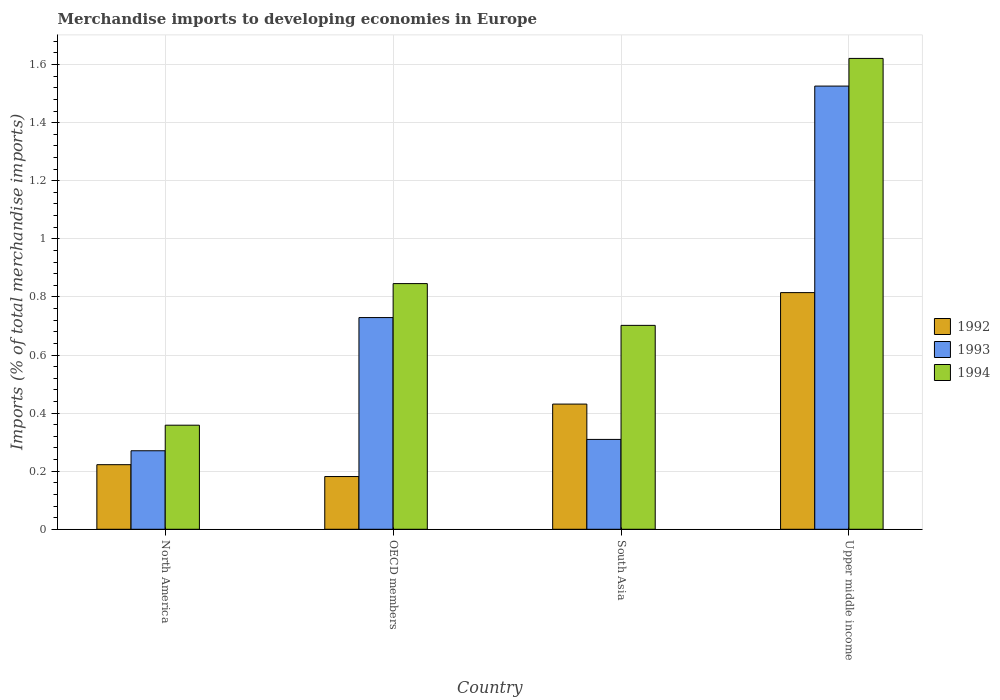How many different coloured bars are there?
Ensure brevity in your answer.  3. Are the number of bars per tick equal to the number of legend labels?
Provide a short and direct response. Yes. How many bars are there on the 3rd tick from the right?
Your answer should be compact. 3. What is the label of the 2nd group of bars from the left?
Ensure brevity in your answer.  OECD members. What is the percentage total merchandise imports in 1992 in South Asia?
Make the answer very short. 0.43. Across all countries, what is the maximum percentage total merchandise imports in 1993?
Keep it short and to the point. 1.53. Across all countries, what is the minimum percentage total merchandise imports in 1994?
Keep it short and to the point. 0.36. In which country was the percentage total merchandise imports in 1994 maximum?
Offer a terse response. Upper middle income. In which country was the percentage total merchandise imports in 1992 minimum?
Provide a succinct answer. OECD members. What is the total percentage total merchandise imports in 1994 in the graph?
Make the answer very short. 3.53. What is the difference between the percentage total merchandise imports in 1992 in North America and that in OECD members?
Your answer should be compact. 0.04. What is the difference between the percentage total merchandise imports in 1994 in North America and the percentage total merchandise imports in 1993 in South Asia?
Your answer should be compact. 0.05. What is the average percentage total merchandise imports in 1994 per country?
Give a very brief answer. 0.88. What is the difference between the percentage total merchandise imports of/in 1993 and percentage total merchandise imports of/in 1992 in Upper middle income?
Your answer should be very brief. 0.71. In how many countries, is the percentage total merchandise imports in 1994 greater than 1.36 %?
Make the answer very short. 1. What is the ratio of the percentage total merchandise imports in 1994 in North America to that in OECD members?
Your answer should be very brief. 0.42. Is the percentage total merchandise imports in 1993 in South Asia less than that in Upper middle income?
Make the answer very short. Yes. What is the difference between the highest and the second highest percentage total merchandise imports in 1992?
Provide a short and direct response. 0.38. What is the difference between the highest and the lowest percentage total merchandise imports in 1993?
Provide a succinct answer. 1.26. In how many countries, is the percentage total merchandise imports in 1994 greater than the average percentage total merchandise imports in 1994 taken over all countries?
Offer a very short reply. 1. Is the sum of the percentage total merchandise imports in 1992 in North America and OECD members greater than the maximum percentage total merchandise imports in 1994 across all countries?
Make the answer very short. No. How many bars are there?
Make the answer very short. 12. Are all the bars in the graph horizontal?
Give a very brief answer. No. What is the difference between two consecutive major ticks on the Y-axis?
Make the answer very short. 0.2. Are the values on the major ticks of Y-axis written in scientific E-notation?
Offer a terse response. No. Does the graph contain any zero values?
Keep it short and to the point. No. Does the graph contain grids?
Your response must be concise. Yes. Where does the legend appear in the graph?
Keep it short and to the point. Center right. What is the title of the graph?
Offer a very short reply. Merchandise imports to developing economies in Europe. Does "1976" appear as one of the legend labels in the graph?
Offer a terse response. No. What is the label or title of the Y-axis?
Ensure brevity in your answer.  Imports (% of total merchandise imports). What is the Imports (% of total merchandise imports) in 1992 in North America?
Provide a succinct answer. 0.22. What is the Imports (% of total merchandise imports) in 1993 in North America?
Your response must be concise. 0.27. What is the Imports (% of total merchandise imports) in 1994 in North America?
Make the answer very short. 0.36. What is the Imports (% of total merchandise imports) in 1992 in OECD members?
Make the answer very short. 0.18. What is the Imports (% of total merchandise imports) of 1993 in OECD members?
Give a very brief answer. 0.73. What is the Imports (% of total merchandise imports) in 1994 in OECD members?
Keep it short and to the point. 0.85. What is the Imports (% of total merchandise imports) in 1992 in South Asia?
Offer a terse response. 0.43. What is the Imports (% of total merchandise imports) of 1993 in South Asia?
Provide a short and direct response. 0.31. What is the Imports (% of total merchandise imports) of 1994 in South Asia?
Keep it short and to the point. 0.7. What is the Imports (% of total merchandise imports) in 1992 in Upper middle income?
Make the answer very short. 0.81. What is the Imports (% of total merchandise imports) of 1993 in Upper middle income?
Offer a terse response. 1.53. What is the Imports (% of total merchandise imports) in 1994 in Upper middle income?
Give a very brief answer. 1.62. Across all countries, what is the maximum Imports (% of total merchandise imports) in 1992?
Keep it short and to the point. 0.81. Across all countries, what is the maximum Imports (% of total merchandise imports) in 1993?
Offer a very short reply. 1.53. Across all countries, what is the maximum Imports (% of total merchandise imports) in 1994?
Offer a terse response. 1.62. Across all countries, what is the minimum Imports (% of total merchandise imports) in 1992?
Ensure brevity in your answer.  0.18. Across all countries, what is the minimum Imports (% of total merchandise imports) in 1993?
Give a very brief answer. 0.27. Across all countries, what is the minimum Imports (% of total merchandise imports) of 1994?
Provide a short and direct response. 0.36. What is the total Imports (% of total merchandise imports) of 1992 in the graph?
Make the answer very short. 1.65. What is the total Imports (% of total merchandise imports) of 1993 in the graph?
Provide a succinct answer. 2.83. What is the total Imports (% of total merchandise imports) in 1994 in the graph?
Provide a succinct answer. 3.53. What is the difference between the Imports (% of total merchandise imports) in 1992 in North America and that in OECD members?
Ensure brevity in your answer.  0.04. What is the difference between the Imports (% of total merchandise imports) in 1993 in North America and that in OECD members?
Provide a short and direct response. -0.46. What is the difference between the Imports (% of total merchandise imports) in 1994 in North America and that in OECD members?
Your answer should be very brief. -0.49. What is the difference between the Imports (% of total merchandise imports) of 1992 in North America and that in South Asia?
Keep it short and to the point. -0.21. What is the difference between the Imports (% of total merchandise imports) in 1993 in North America and that in South Asia?
Give a very brief answer. -0.04. What is the difference between the Imports (% of total merchandise imports) in 1994 in North America and that in South Asia?
Keep it short and to the point. -0.34. What is the difference between the Imports (% of total merchandise imports) in 1992 in North America and that in Upper middle income?
Offer a terse response. -0.59. What is the difference between the Imports (% of total merchandise imports) in 1993 in North America and that in Upper middle income?
Your response must be concise. -1.26. What is the difference between the Imports (% of total merchandise imports) in 1994 in North America and that in Upper middle income?
Provide a short and direct response. -1.26. What is the difference between the Imports (% of total merchandise imports) in 1992 in OECD members and that in South Asia?
Make the answer very short. -0.25. What is the difference between the Imports (% of total merchandise imports) of 1993 in OECD members and that in South Asia?
Provide a short and direct response. 0.42. What is the difference between the Imports (% of total merchandise imports) of 1994 in OECD members and that in South Asia?
Make the answer very short. 0.14. What is the difference between the Imports (% of total merchandise imports) of 1992 in OECD members and that in Upper middle income?
Keep it short and to the point. -0.63. What is the difference between the Imports (% of total merchandise imports) of 1993 in OECD members and that in Upper middle income?
Provide a succinct answer. -0.8. What is the difference between the Imports (% of total merchandise imports) in 1994 in OECD members and that in Upper middle income?
Provide a short and direct response. -0.78. What is the difference between the Imports (% of total merchandise imports) of 1992 in South Asia and that in Upper middle income?
Ensure brevity in your answer.  -0.38. What is the difference between the Imports (% of total merchandise imports) in 1993 in South Asia and that in Upper middle income?
Provide a succinct answer. -1.22. What is the difference between the Imports (% of total merchandise imports) of 1994 in South Asia and that in Upper middle income?
Ensure brevity in your answer.  -0.92. What is the difference between the Imports (% of total merchandise imports) of 1992 in North America and the Imports (% of total merchandise imports) of 1993 in OECD members?
Your answer should be compact. -0.51. What is the difference between the Imports (% of total merchandise imports) in 1992 in North America and the Imports (% of total merchandise imports) in 1994 in OECD members?
Make the answer very short. -0.62. What is the difference between the Imports (% of total merchandise imports) of 1993 in North America and the Imports (% of total merchandise imports) of 1994 in OECD members?
Offer a terse response. -0.58. What is the difference between the Imports (% of total merchandise imports) in 1992 in North America and the Imports (% of total merchandise imports) in 1993 in South Asia?
Offer a very short reply. -0.09. What is the difference between the Imports (% of total merchandise imports) of 1992 in North America and the Imports (% of total merchandise imports) of 1994 in South Asia?
Make the answer very short. -0.48. What is the difference between the Imports (% of total merchandise imports) in 1993 in North America and the Imports (% of total merchandise imports) in 1994 in South Asia?
Ensure brevity in your answer.  -0.43. What is the difference between the Imports (% of total merchandise imports) of 1992 in North America and the Imports (% of total merchandise imports) of 1993 in Upper middle income?
Give a very brief answer. -1.3. What is the difference between the Imports (% of total merchandise imports) of 1992 in North America and the Imports (% of total merchandise imports) of 1994 in Upper middle income?
Make the answer very short. -1.4. What is the difference between the Imports (% of total merchandise imports) of 1993 in North America and the Imports (% of total merchandise imports) of 1994 in Upper middle income?
Keep it short and to the point. -1.35. What is the difference between the Imports (% of total merchandise imports) in 1992 in OECD members and the Imports (% of total merchandise imports) in 1993 in South Asia?
Ensure brevity in your answer.  -0.13. What is the difference between the Imports (% of total merchandise imports) of 1992 in OECD members and the Imports (% of total merchandise imports) of 1994 in South Asia?
Ensure brevity in your answer.  -0.52. What is the difference between the Imports (% of total merchandise imports) of 1993 in OECD members and the Imports (% of total merchandise imports) of 1994 in South Asia?
Your response must be concise. 0.03. What is the difference between the Imports (% of total merchandise imports) in 1992 in OECD members and the Imports (% of total merchandise imports) in 1993 in Upper middle income?
Keep it short and to the point. -1.34. What is the difference between the Imports (% of total merchandise imports) of 1992 in OECD members and the Imports (% of total merchandise imports) of 1994 in Upper middle income?
Make the answer very short. -1.44. What is the difference between the Imports (% of total merchandise imports) in 1993 in OECD members and the Imports (% of total merchandise imports) in 1994 in Upper middle income?
Ensure brevity in your answer.  -0.89. What is the difference between the Imports (% of total merchandise imports) in 1992 in South Asia and the Imports (% of total merchandise imports) in 1993 in Upper middle income?
Keep it short and to the point. -1.09. What is the difference between the Imports (% of total merchandise imports) of 1992 in South Asia and the Imports (% of total merchandise imports) of 1994 in Upper middle income?
Your response must be concise. -1.19. What is the difference between the Imports (% of total merchandise imports) of 1993 in South Asia and the Imports (% of total merchandise imports) of 1994 in Upper middle income?
Your answer should be very brief. -1.31. What is the average Imports (% of total merchandise imports) of 1992 per country?
Give a very brief answer. 0.41. What is the average Imports (% of total merchandise imports) of 1993 per country?
Your answer should be compact. 0.71. What is the average Imports (% of total merchandise imports) in 1994 per country?
Your response must be concise. 0.88. What is the difference between the Imports (% of total merchandise imports) in 1992 and Imports (% of total merchandise imports) in 1993 in North America?
Make the answer very short. -0.05. What is the difference between the Imports (% of total merchandise imports) in 1992 and Imports (% of total merchandise imports) in 1994 in North America?
Keep it short and to the point. -0.14. What is the difference between the Imports (% of total merchandise imports) in 1993 and Imports (% of total merchandise imports) in 1994 in North America?
Give a very brief answer. -0.09. What is the difference between the Imports (% of total merchandise imports) of 1992 and Imports (% of total merchandise imports) of 1993 in OECD members?
Keep it short and to the point. -0.55. What is the difference between the Imports (% of total merchandise imports) in 1992 and Imports (% of total merchandise imports) in 1994 in OECD members?
Offer a terse response. -0.66. What is the difference between the Imports (% of total merchandise imports) of 1993 and Imports (% of total merchandise imports) of 1994 in OECD members?
Make the answer very short. -0.12. What is the difference between the Imports (% of total merchandise imports) of 1992 and Imports (% of total merchandise imports) of 1993 in South Asia?
Your answer should be very brief. 0.12. What is the difference between the Imports (% of total merchandise imports) of 1992 and Imports (% of total merchandise imports) of 1994 in South Asia?
Keep it short and to the point. -0.27. What is the difference between the Imports (% of total merchandise imports) in 1993 and Imports (% of total merchandise imports) in 1994 in South Asia?
Ensure brevity in your answer.  -0.39. What is the difference between the Imports (% of total merchandise imports) in 1992 and Imports (% of total merchandise imports) in 1993 in Upper middle income?
Your answer should be very brief. -0.71. What is the difference between the Imports (% of total merchandise imports) of 1992 and Imports (% of total merchandise imports) of 1994 in Upper middle income?
Offer a terse response. -0.81. What is the difference between the Imports (% of total merchandise imports) of 1993 and Imports (% of total merchandise imports) of 1994 in Upper middle income?
Ensure brevity in your answer.  -0.1. What is the ratio of the Imports (% of total merchandise imports) of 1992 in North America to that in OECD members?
Your response must be concise. 1.23. What is the ratio of the Imports (% of total merchandise imports) of 1993 in North America to that in OECD members?
Offer a very short reply. 0.37. What is the ratio of the Imports (% of total merchandise imports) of 1994 in North America to that in OECD members?
Keep it short and to the point. 0.42. What is the ratio of the Imports (% of total merchandise imports) in 1992 in North America to that in South Asia?
Provide a succinct answer. 0.52. What is the ratio of the Imports (% of total merchandise imports) of 1993 in North America to that in South Asia?
Make the answer very short. 0.87. What is the ratio of the Imports (% of total merchandise imports) of 1994 in North America to that in South Asia?
Offer a terse response. 0.51. What is the ratio of the Imports (% of total merchandise imports) of 1992 in North America to that in Upper middle income?
Give a very brief answer. 0.27. What is the ratio of the Imports (% of total merchandise imports) of 1993 in North America to that in Upper middle income?
Keep it short and to the point. 0.18. What is the ratio of the Imports (% of total merchandise imports) of 1994 in North America to that in Upper middle income?
Give a very brief answer. 0.22. What is the ratio of the Imports (% of total merchandise imports) of 1992 in OECD members to that in South Asia?
Ensure brevity in your answer.  0.42. What is the ratio of the Imports (% of total merchandise imports) of 1993 in OECD members to that in South Asia?
Provide a succinct answer. 2.36. What is the ratio of the Imports (% of total merchandise imports) in 1994 in OECD members to that in South Asia?
Offer a very short reply. 1.2. What is the ratio of the Imports (% of total merchandise imports) of 1992 in OECD members to that in Upper middle income?
Your response must be concise. 0.22. What is the ratio of the Imports (% of total merchandise imports) in 1993 in OECD members to that in Upper middle income?
Provide a short and direct response. 0.48. What is the ratio of the Imports (% of total merchandise imports) of 1994 in OECD members to that in Upper middle income?
Keep it short and to the point. 0.52. What is the ratio of the Imports (% of total merchandise imports) of 1992 in South Asia to that in Upper middle income?
Your response must be concise. 0.53. What is the ratio of the Imports (% of total merchandise imports) of 1993 in South Asia to that in Upper middle income?
Give a very brief answer. 0.2. What is the ratio of the Imports (% of total merchandise imports) in 1994 in South Asia to that in Upper middle income?
Provide a short and direct response. 0.43. What is the difference between the highest and the second highest Imports (% of total merchandise imports) of 1992?
Ensure brevity in your answer.  0.38. What is the difference between the highest and the second highest Imports (% of total merchandise imports) of 1993?
Offer a terse response. 0.8. What is the difference between the highest and the second highest Imports (% of total merchandise imports) of 1994?
Your response must be concise. 0.78. What is the difference between the highest and the lowest Imports (% of total merchandise imports) of 1992?
Your answer should be compact. 0.63. What is the difference between the highest and the lowest Imports (% of total merchandise imports) of 1993?
Keep it short and to the point. 1.26. What is the difference between the highest and the lowest Imports (% of total merchandise imports) in 1994?
Your response must be concise. 1.26. 